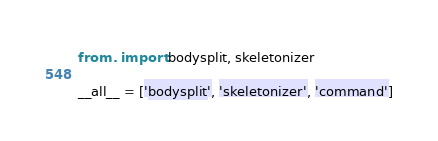<code> <loc_0><loc_0><loc_500><loc_500><_Python_>from . import bodysplit, skeletonizer

__all__ = ['bodysplit', 'skeletonizer', 'command']
</code> 